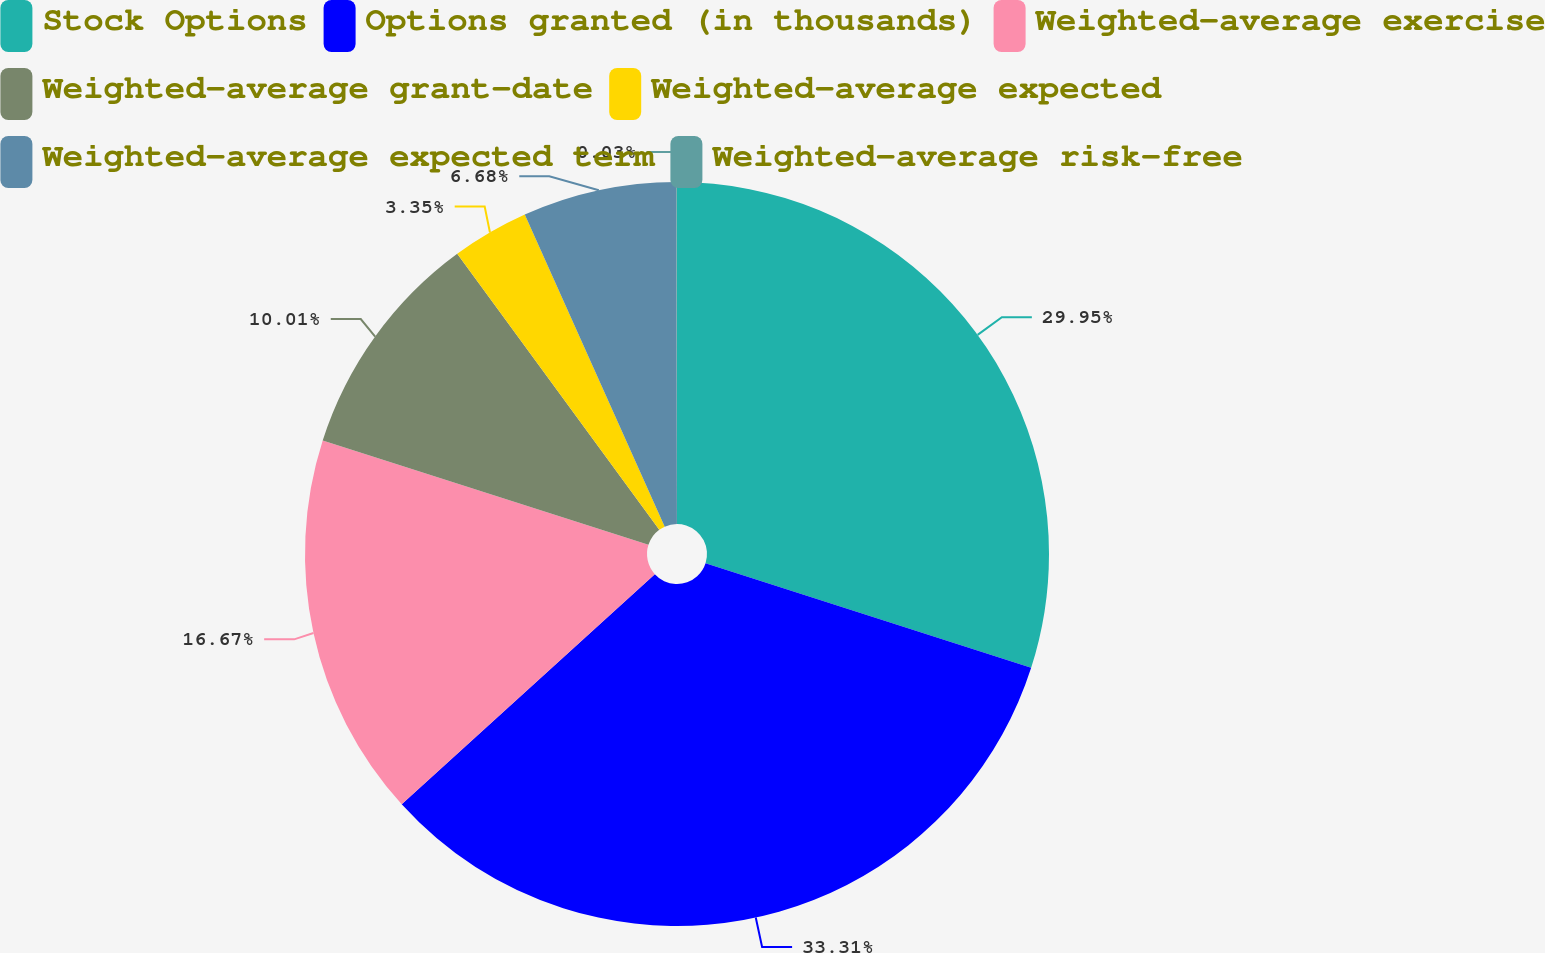Convert chart to OTSL. <chart><loc_0><loc_0><loc_500><loc_500><pie_chart><fcel>Stock Options<fcel>Options granted (in thousands)<fcel>Weighted-average exercise<fcel>Weighted-average grant-date<fcel>Weighted-average expected<fcel>Weighted-average expected term<fcel>Weighted-average risk-free<nl><fcel>29.95%<fcel>33.31%<fcel>16.67%<fcel>10.01%<fcel>3.35%<fcel>6.68%<fcel>0.03%<nl></chart> 